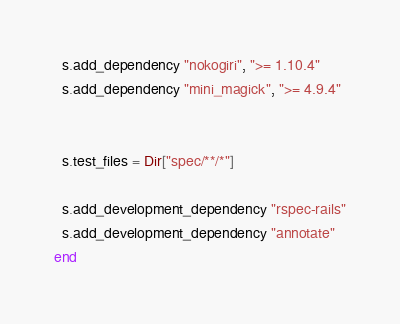<code> <loc_0><loc_0><loc_500><loc_500><_Ruby_>
  s.add_dependency "nokogiri", ">= 1.10.4"
  s.add_dependency "mini_magick", ">= 4.9.4"


  s.test_files = Dir["spec/**/*"]

  s.add_development_dependency "rspec-rails"
  s.add_development_dependency "annotate"
end
</code> 